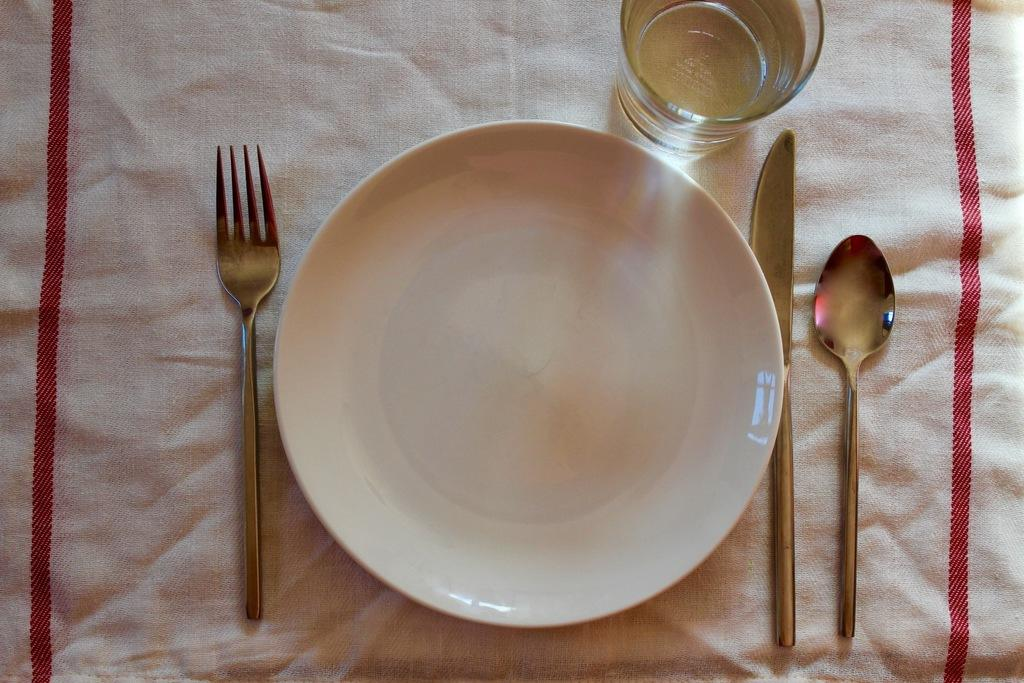What is on the plate that is visible in the image? There is an empty plate in the image. What utensils can be seen in the image? There is a fork, a spoon, and a knife in the image. What is in the glass that is visible in the image? There is a glass filled with water in the image. What is under the plate in the image? There is a cloth under the plate in the image. What type of tramp is visible in the image? There is no tramp present in the image. What is the consistency of the oatmeal in the image? There is no oatmeal present in the image. 